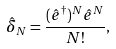Convert formula to latex. <formula><loc_0><loc_0><loc_500><loc_500>\hat { \delta } _ { N } = \frac { ( \hat { e } ^ { \dagger } ) ^ { N } \hat { e } ^ { N } } { N ! } ,</formula> 